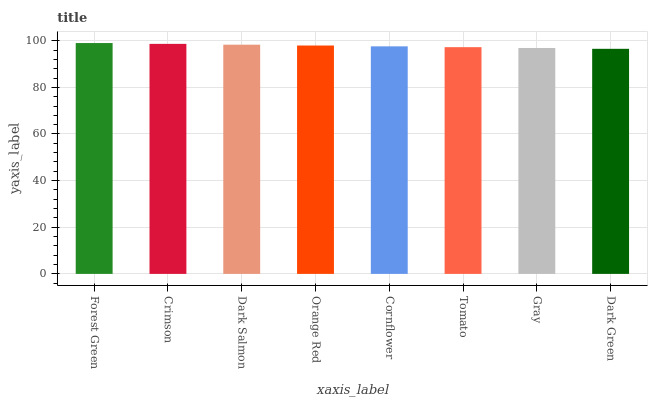Is Crimson the minimum?
Answer yes or no. No. Is Crimson the maximum?
Answer yes or no. No. Is Forest Green greater than Crimson?
Answer yes or no. Yes. Is Crimson less than Forest Green?
Answer yes or no. Yes. Is Crimson greater than Forest Green?
Answer yes or no. No. Is Forest Green less than Crimson?
Answer yes or no. No. Is Orange Red the high median?
Answer yes or no. Yes. Is Cornflower the low median?
Answer yes or no. Yes. Is Dark Green the high median?
Answer yes or no. No. Is Gray the low median?
Answer yes or no. No. 